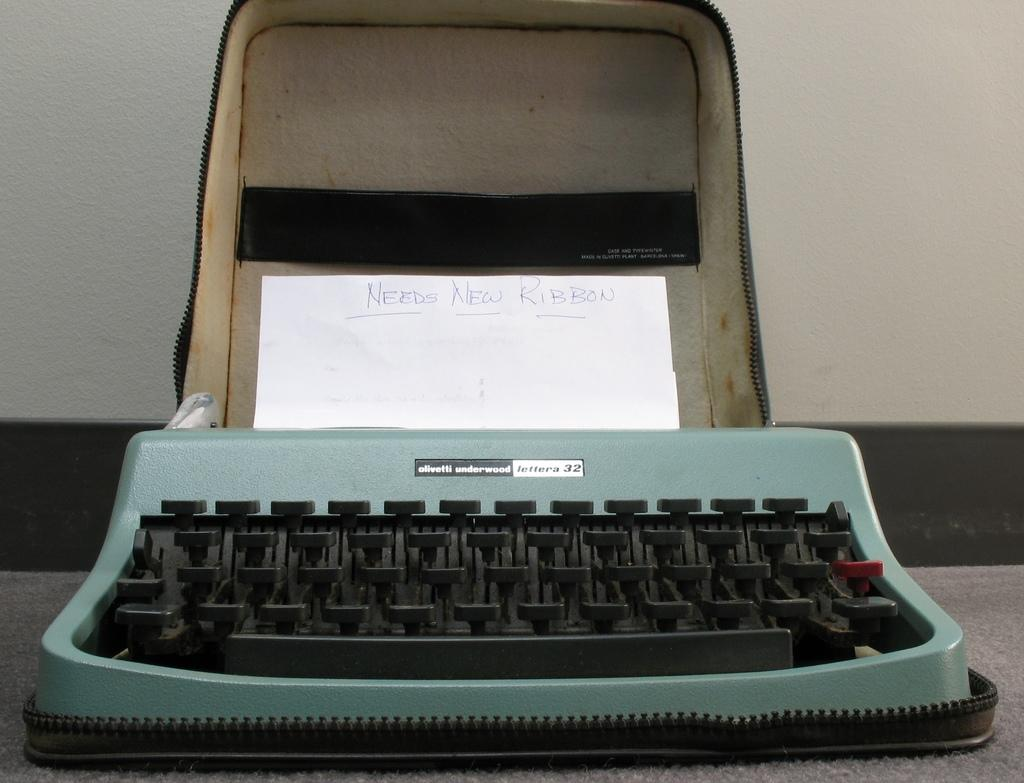Provide a one-sentence caption for the provided image. An olivetti underwood lettera 32 typewriter containing a piece of paper that says Needs New Ribbon. 